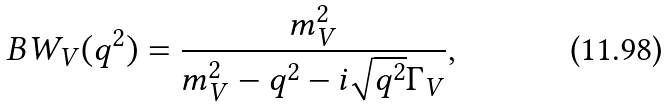Convert formula to latex. <formula><loc_0><loc_0><loc_500><loc_500>B W _ { V } ( q ^ { 2 } ) = \frac { m _ { V } ^ { 2 } } { m _ { V } ^ { 2 } - q ^ { 2 } - i \sqrt { q ^ { 2 } } \Gamma _ { V } } ,</formula> 